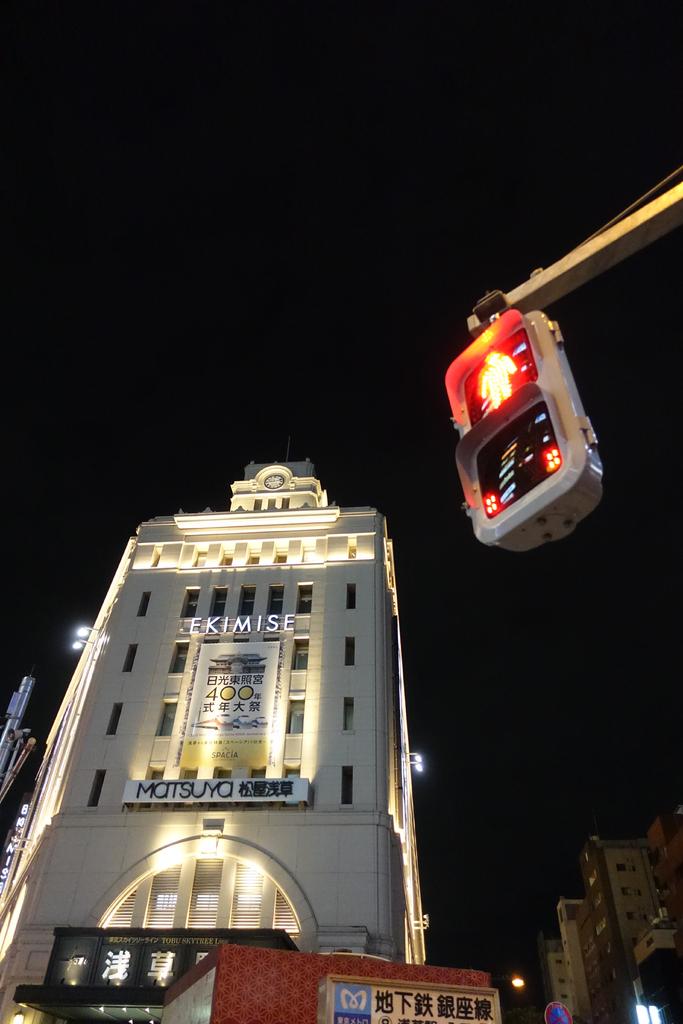Is that  russian hotel?
Keep it short and to the point. Unanswerable. What is the name of this company?
Ensure brevity in your answer.  Ekimise. 